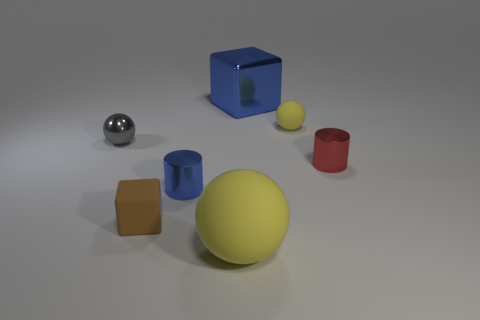Subtract all cyan cubes. How many yellow balls are left? 2 Add 3 big blue cubes. How many objects exist? 10 Subtract all cylinders. How many objects are left? 5 Add 4 small yellow objects. How many small yellow objects exist? 5 Subtract 0 cyan cubes. How many objects are left? 7 Subtract all large purple things. Subtract all big yellow things. How many objects are left? 6 Add 4 gray metal things. How many gray metal things are left? 5 